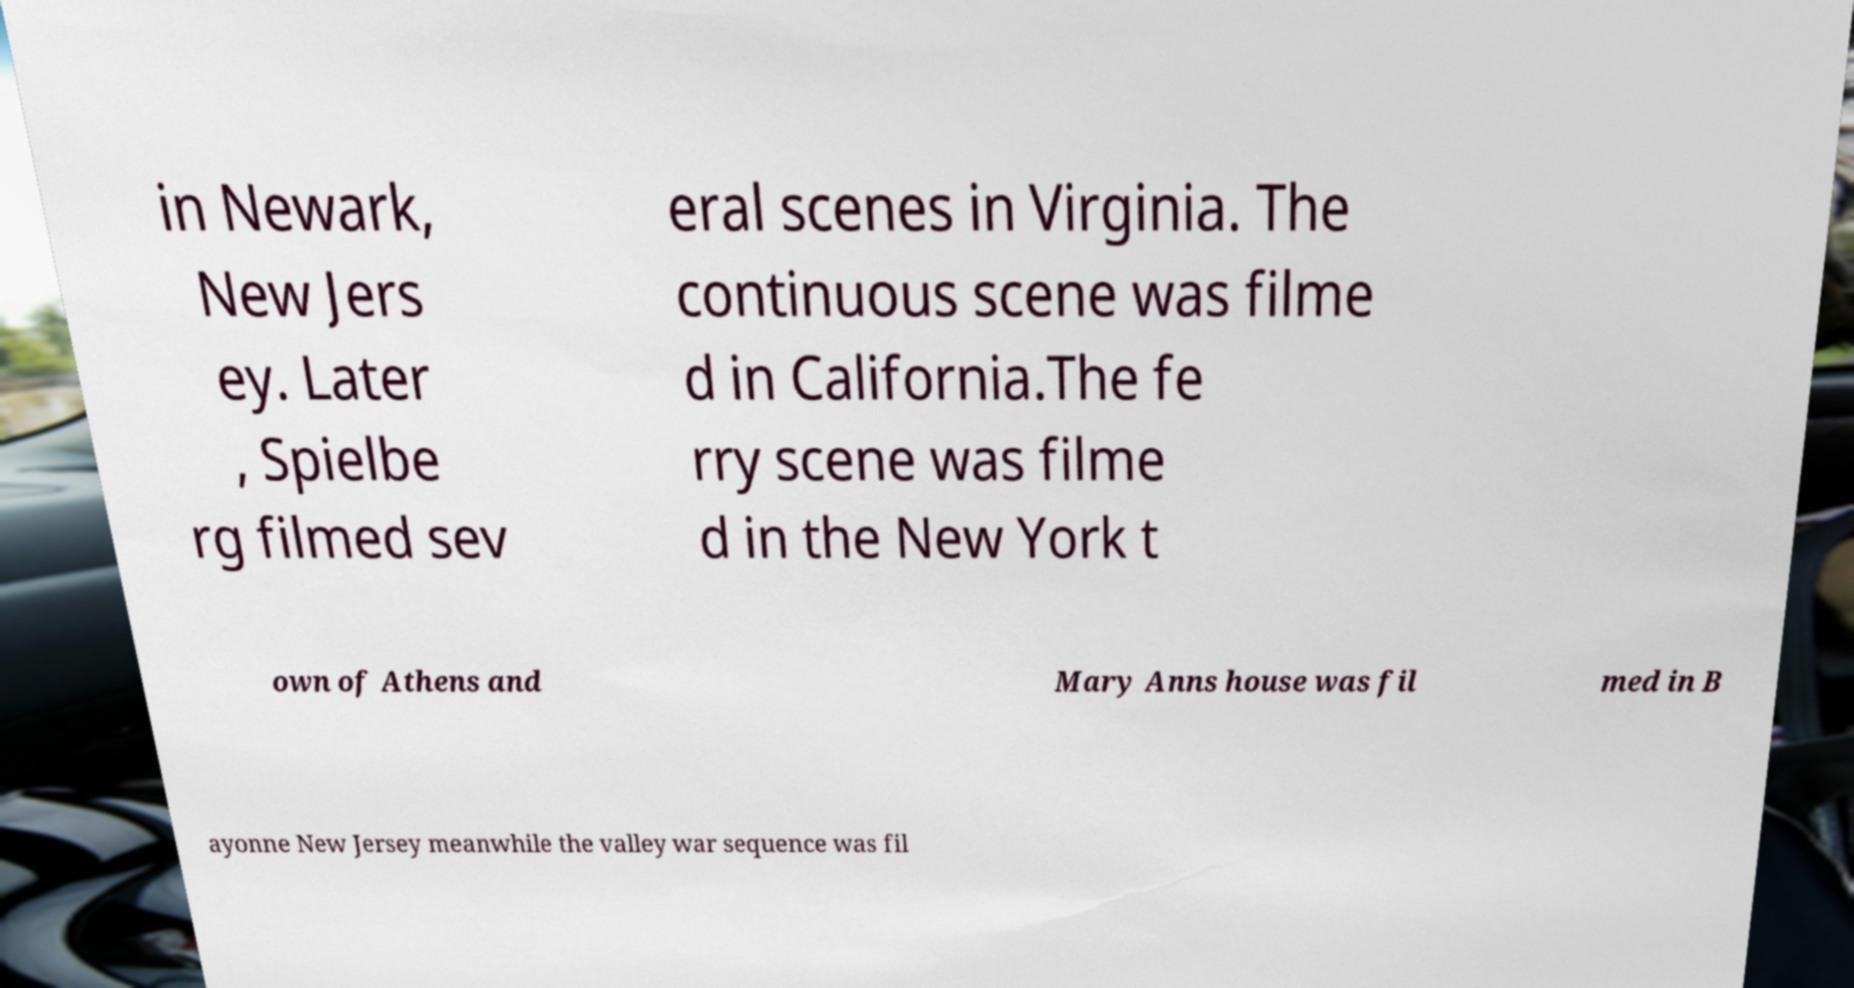Please read and relay the text visible in this image. What does it say? in Newark, New Jers ey. Later , Spielbe rg filmed sev eral scenes in Virginia. The continuous scene was filme d in California.The fe rry scene was filme d in the New York t own of Athens and Mary Anns house was fil med in B ayonne New Jersey meanwhile the valley war sequence was fil 